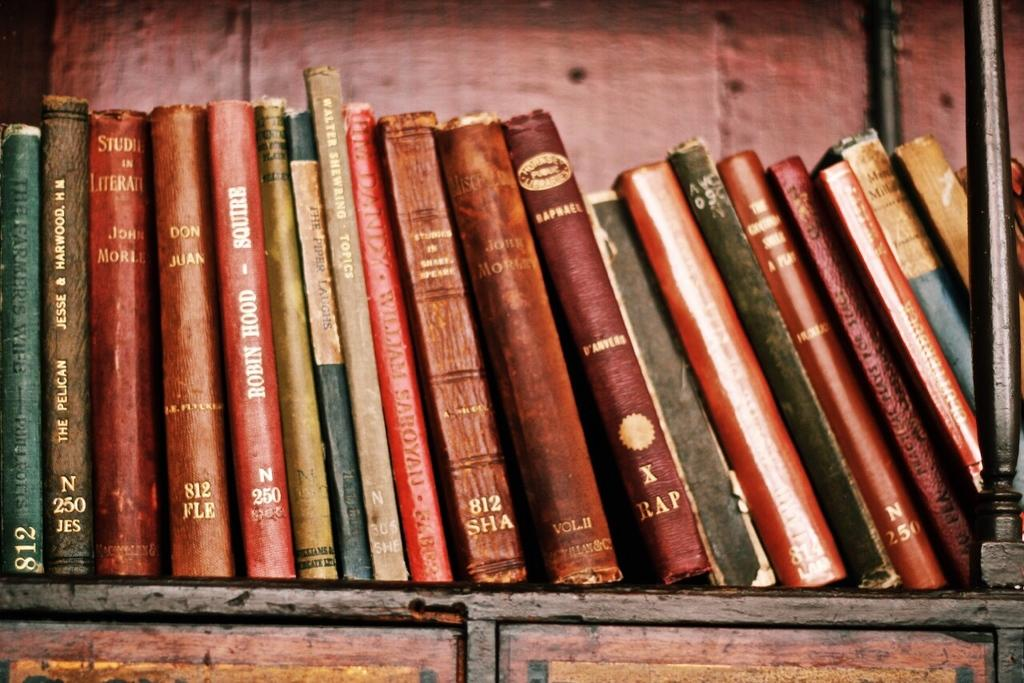What objects can be seen in the image? There are books in the image. Where are the books located? The books are on a rack. What color is the body of the person reading the books in the image? There is no person reading the books in the image, and therefore no body or color can be observed. 